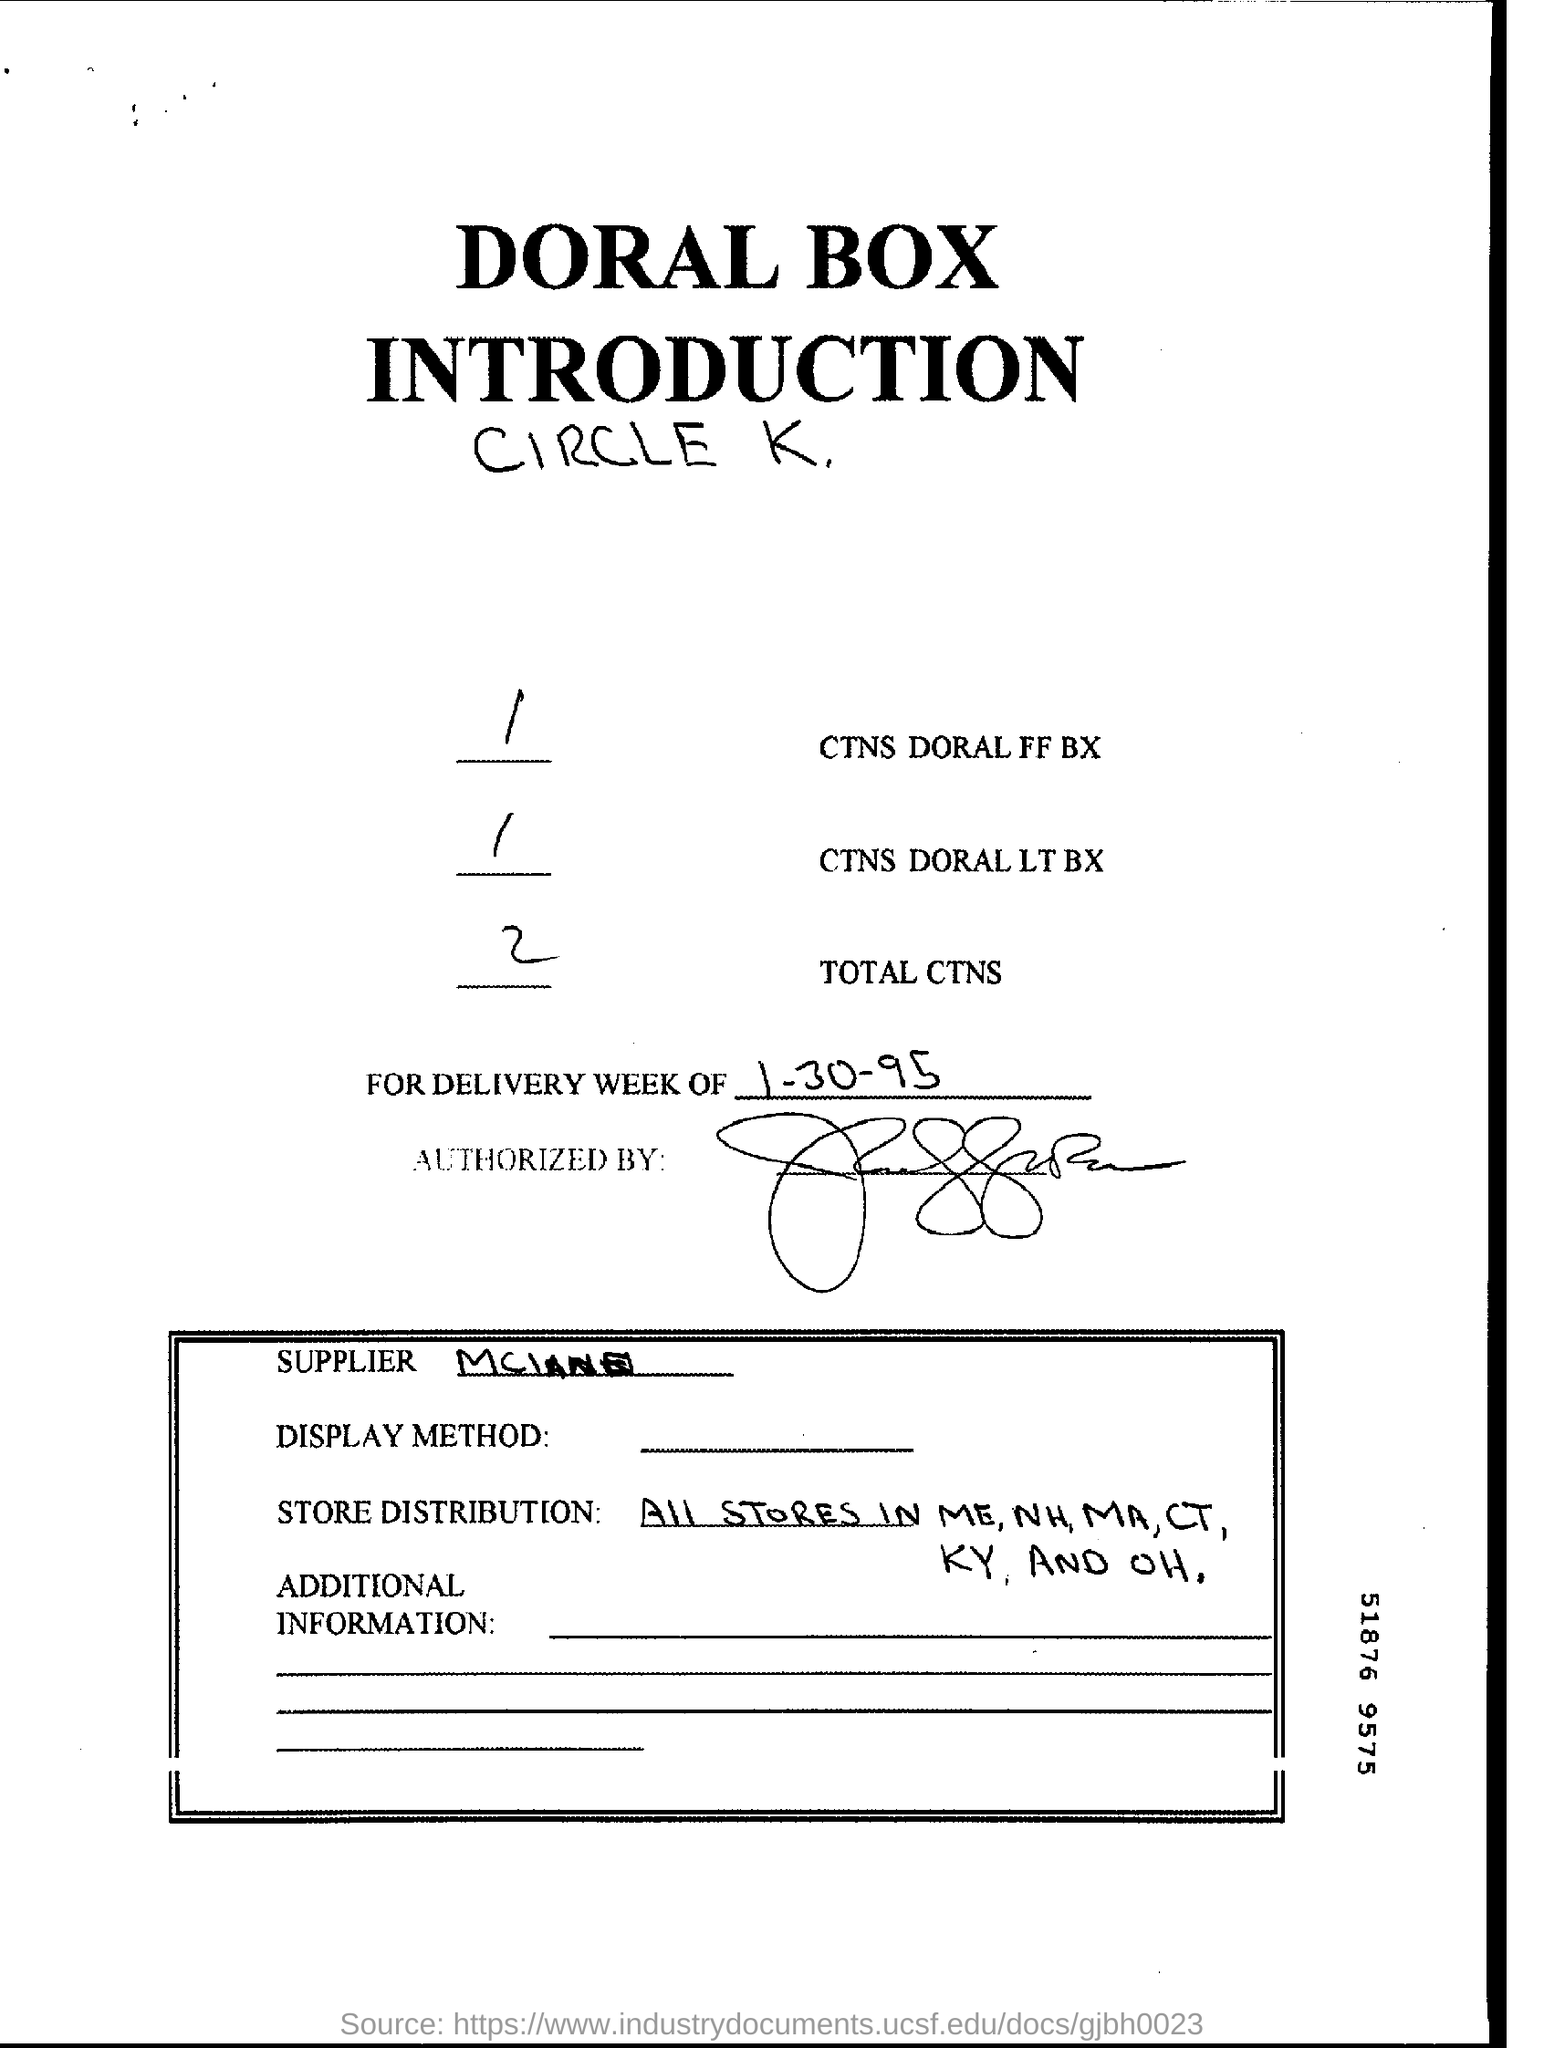Point out several critical features in this image. The date mentioned in the document is January 30, 1995. The total cost of non-sales transactions (CTNS) field contains the value of the total cost of non-sales transactions, as recorded in the system. The letterhead contains the written phrase "Doral Box. 